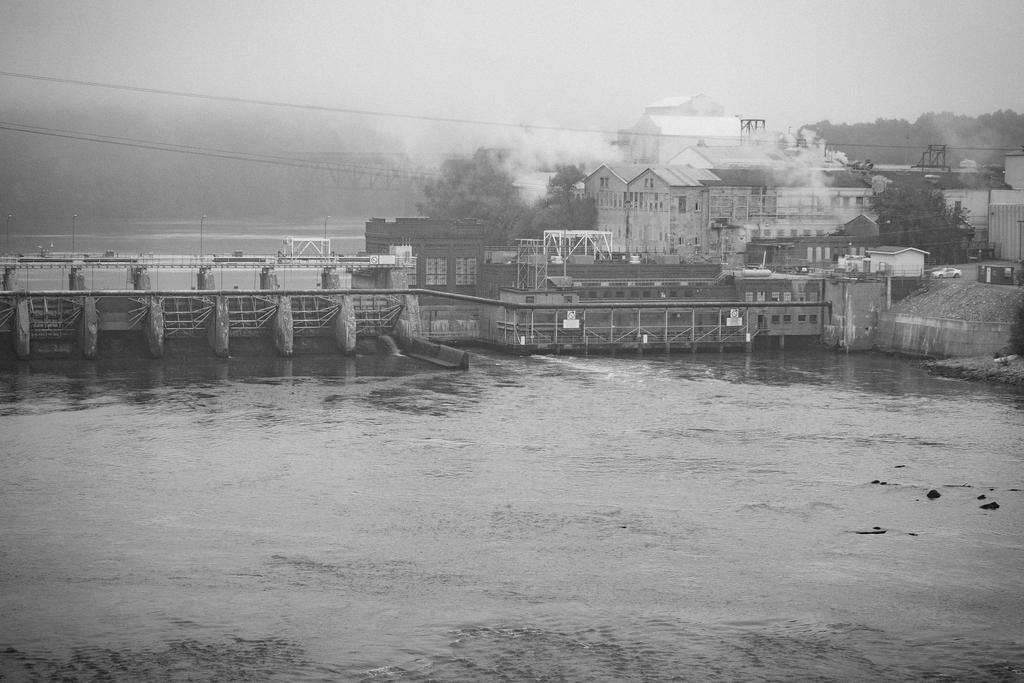Please provide a concise description of this image. This picture shows water and we see few buildings and a bridge and we see trees and smoke and a cloudy sky. 